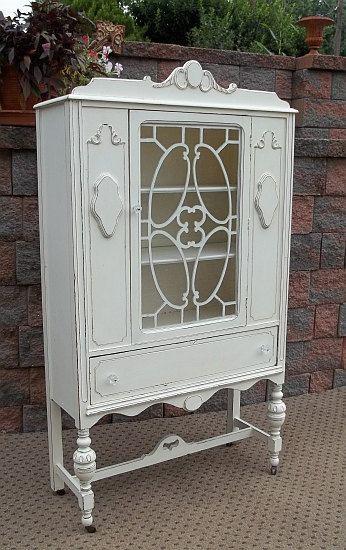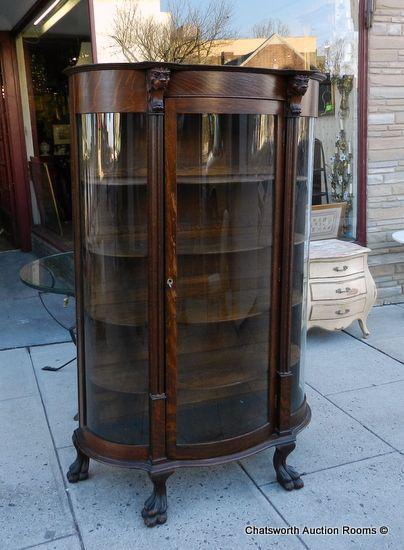The first image is the image on the left, the second image is the image on the right. Assess this claim about the two images: "At least one of the images contains an object inside a hutch.". Correct or not? Answer yes or no. No. The first image is the image on the left, the second image is the image on the right. For the images displayed, is the sentence "An image shows a white cabinet with a decorative top element, centered glass panel, and slender legs." factually correct? Answer yes or no. Yes. 